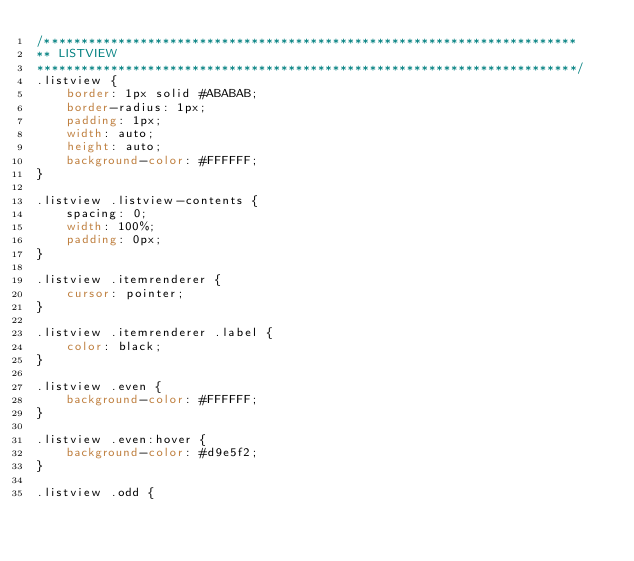Convert code to text. <code><loc_0><loc_0><loc_500><loc_500><_CSS_>/************************************************************************
** LISTVIEW
*************************************************************************/
.listview {
    border: 1px solid #ABABAB;
    border-radius: 1px;
    padding: 1px;
    width: auto;
    height: auto;
    background-color: #FFFFFF;
}

.listview .listview-contents {
    spacing: 0;
    width: 100%;
    padding: 0px;
}

.listview .itemrenderer {
    cursor: pointer;    
}

.listview .itemrenderer .label {
    color: black;
}

.listview .even {
    background-color: #FFFFFF;
}

.listview .even:hover {
    background-color: #d9e5f2;
}

.listview .odd {</code> 